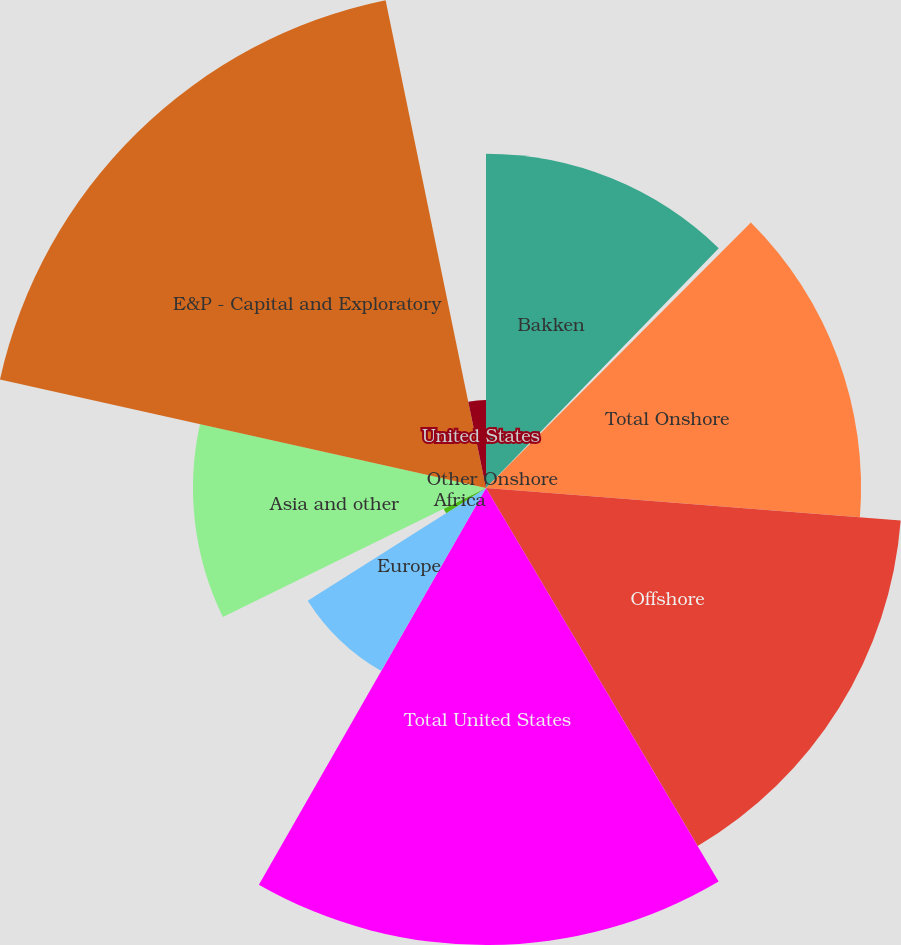Convert chart to OTSL. <chart><loc_0><loc_0><loc_500><loc_500><pie_chart><fcel>Bakken<fcel>Other Onshore<fcel>Total Onshore<fcel>Offshore<fcel>Total United States<fcel>Europe<fcel>Africa<fcel>Asia and other<fcel>E&P - Capital and Exploratory<fcel>United States<nl><fcel>12.26%<fcel>0.22%<fcel>13.76%<fcel>15.26%<fcel>16.77%<fcel>7.74%<fcel>1.73%<fcel>10.75%<fcel>18.27%<fcel>3.23%<nl></chart> 